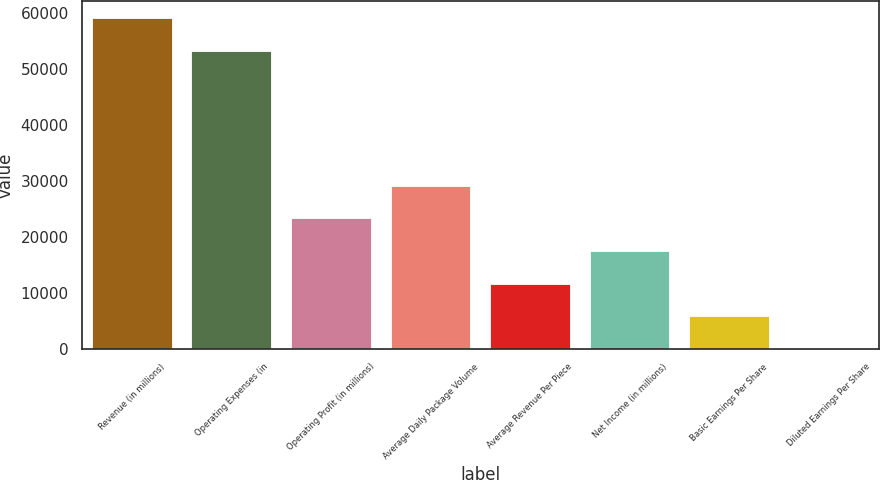<chart> <loc_0><loc_0><loc_500><loc_500><bar_chart><fcel>Revenue (in millions)<fcel>Operating Expenses (in<fcel>Operating Profit (in millions)<fcel>Average Daily Package Volume<fcel>Average Revenue Per Piece<fcel>Net Income (in millions)<fcel>Basic Earnings Per Share<fcel>Diluted Earnings Per Share<nl><fcel>59086.9<fcel>53264<fcel>23294.8<fcel>29117.6<fcel>11649<fcel>17471.9<fcel>5826.15<fcel>3.28<nl></chart> 